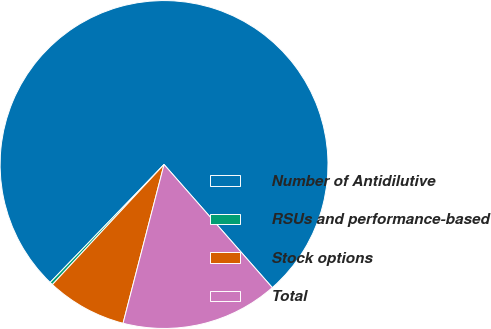<chart> <loc_0><loc_0><loc_500><loc_500><pie_chart><fcel>Number of Antidilutive<fcel>RSUs and performance-based<fcel>Stock options<fcel>Total<nl><fcel>76.29%<fcel>0.3%<fcel>7.9%<fcel>15.5%<nl></chart> 